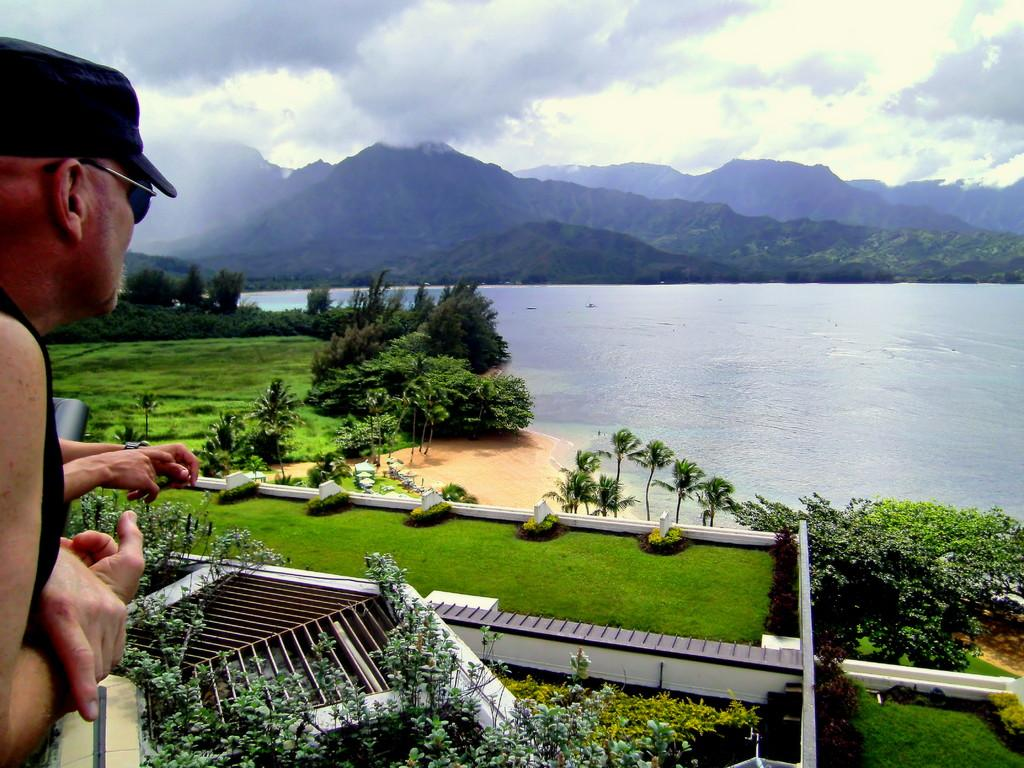Who or what is present in the image? There is a person in the image. What part of the person's body can be seen in the image? There is a person's hand in the image. What type of natural environment is depicted in the image? There are trees, grass, sand, water, and mountains in the image. What part of the sky is visible in the image? The sky is visible in the image. What type of watch is the person wearing in the image? There is no watch visible in the image. How many children are present in the image? There are no children present in the image. 